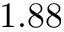Convert formula to latex. <formula><loc_0><loc_0><loc_500><loc_500>1 . 8 8</formula> 